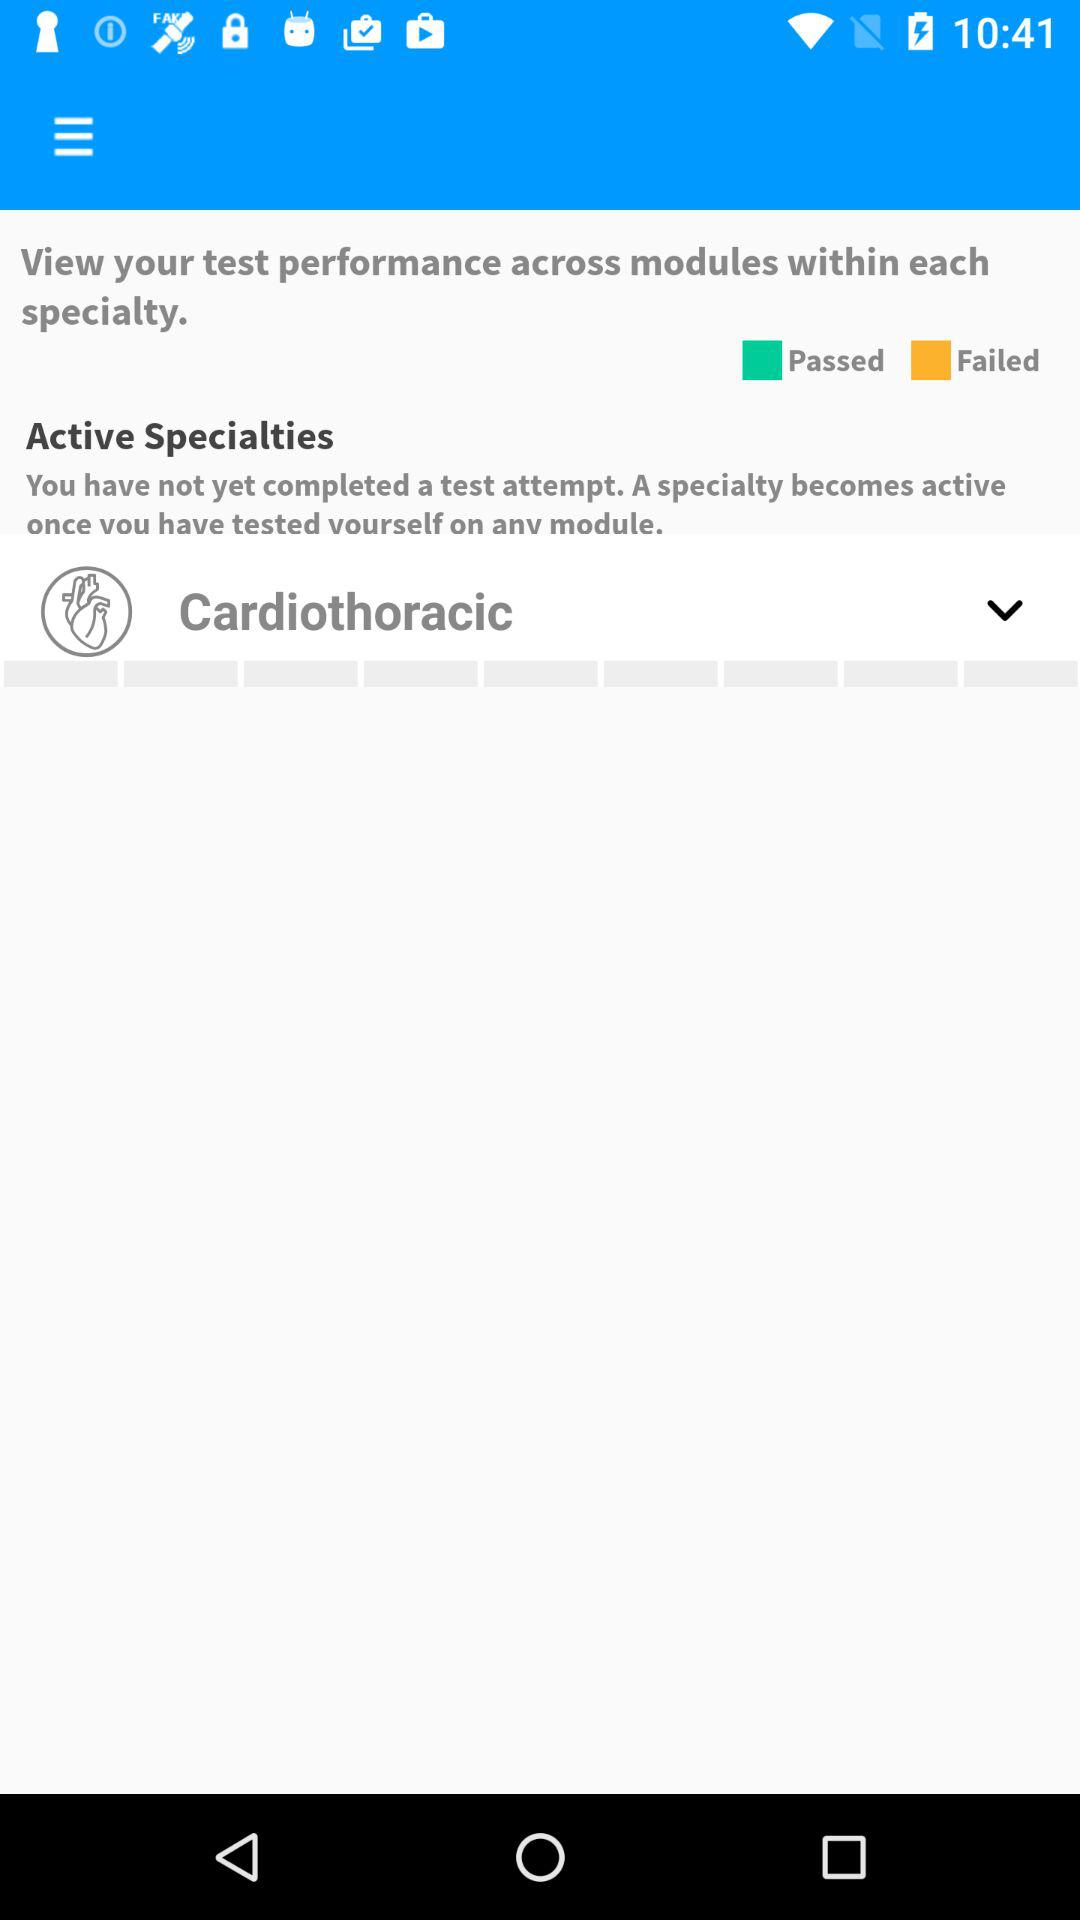What specialty is shown under "Active Specialties"? The specialty shown under "Active Specialties" is cardiothoracic. 